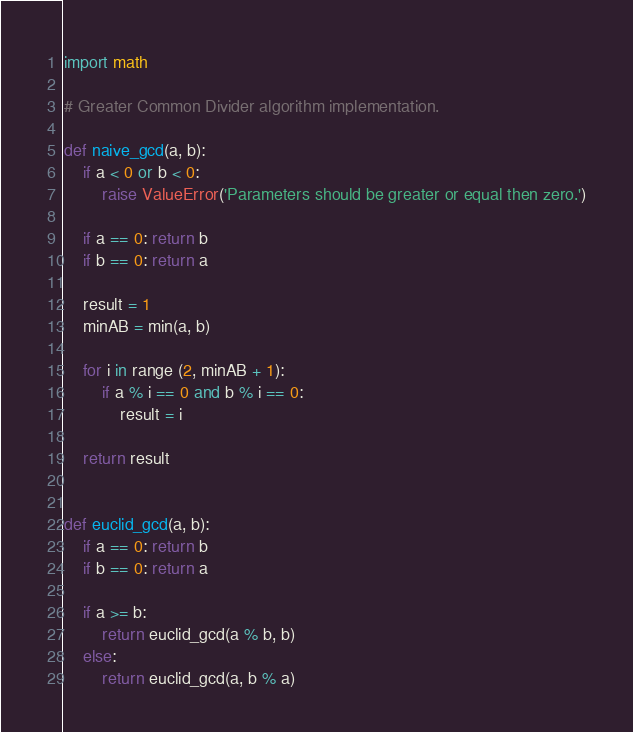Convert code to text. <code><loc_0><loc_0><loc_500><loc_500><_Python_>import math

# Greater Common Divider algorithm implementation.

def naive_gcd(a, b):
    if a < 0 or b < 0:
        raise ValueError('Parameters should be greater or equal then zero.')

    if a == 0: return b
    if b == 0: return a

    result = 1
    minAB = min(a, b)

    for i in range (2, minAB + 1):
        if a % i == 0 and b % i == 0:
            result = i

    return result


def euclid_gcd(a, b):
    if a == 0: return b
    if b == 0: return a

    if a >= b:
        return euclid_gcd(a % b, b)
    else:
        return euclid_gcd(a, b % a)
</code> 